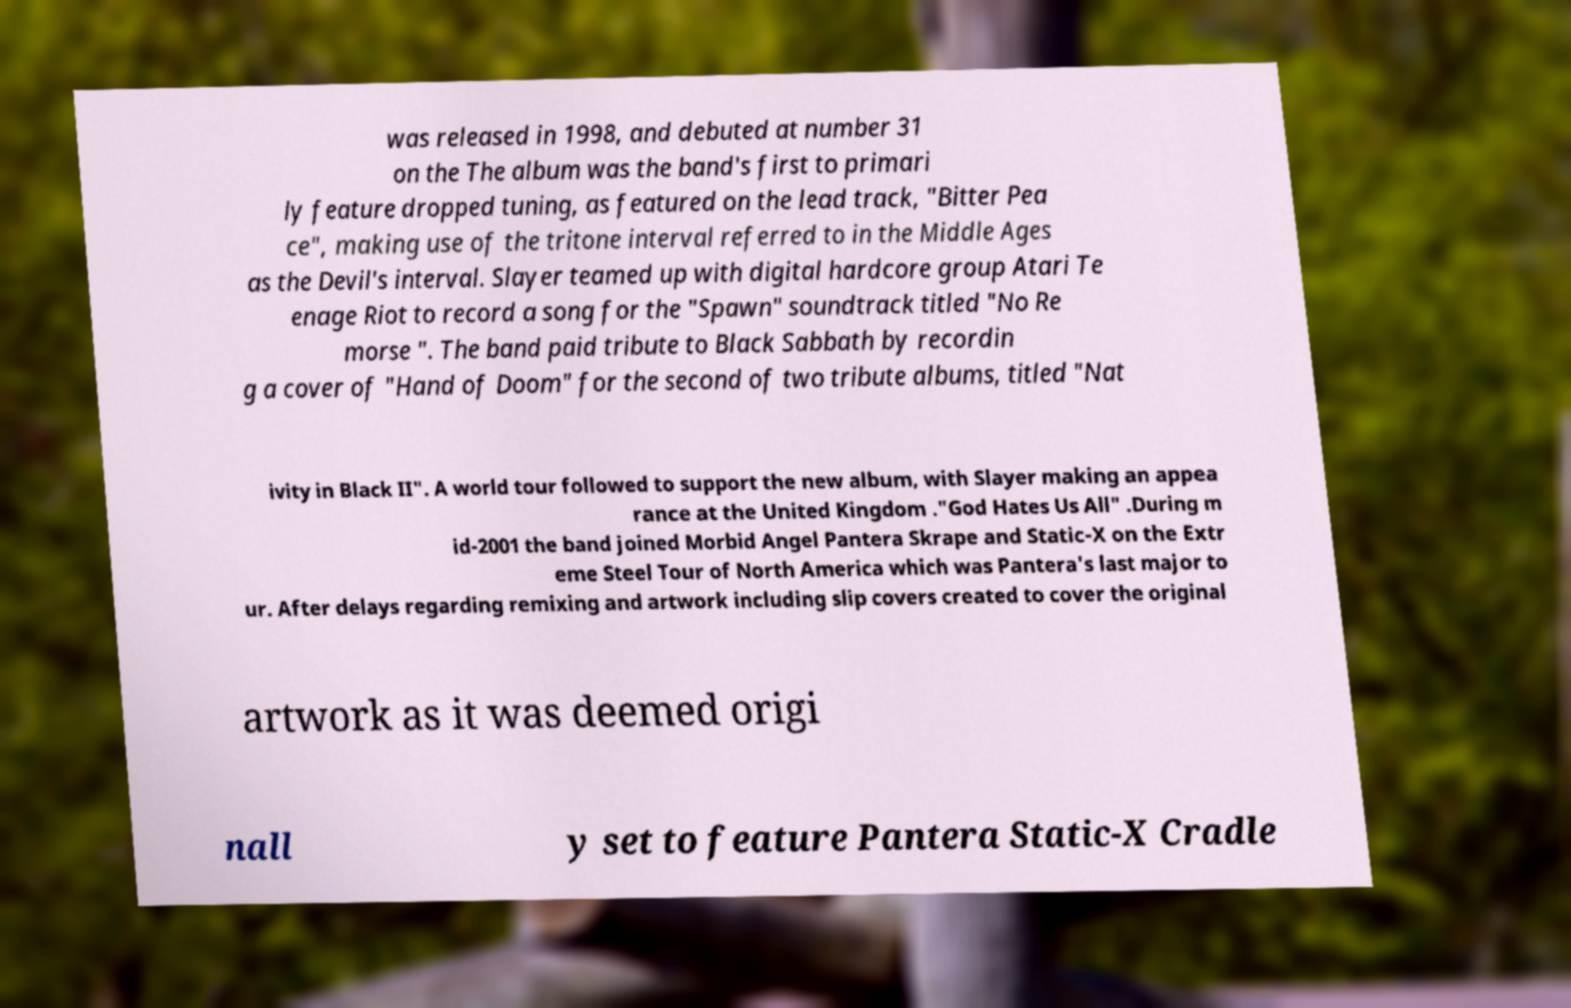For documentation purposes, I need the text within this image transcribed. Could you provide that? was released in 1998, and debuted at number 31 on the The album was the band's first to primari ly feature dropped tuning, as featured on the lead track, "Bitter Pea ce", making use of the tritone interval referred to in the Middle Ages as the Devil's interval. Slayer teamed up with digital hardcore group Atari Te enage Riot to record a song for the "Spawn" soundtrack titled "No Re morse ". The band paid tribute to Black Sabbath by recordin g a cover of "Hand of Doom" for the second of two tribute albums, titled "Nat ivity in Black II". A world tour followed to support the new album, with Slayer making an appea rance at the United Kingdom ."God Hates Us All" .During m id-2001 the band joined Morbid Angel Pantera Skrape and Static-X on the Extr eme Steel Tour of North America which was Pantera's last major to ur. After delays regarding remixing and artwork including slip covers created to cover the original artwork as it was deemed origi nall y set to feature Pantera Static-X Cradle 